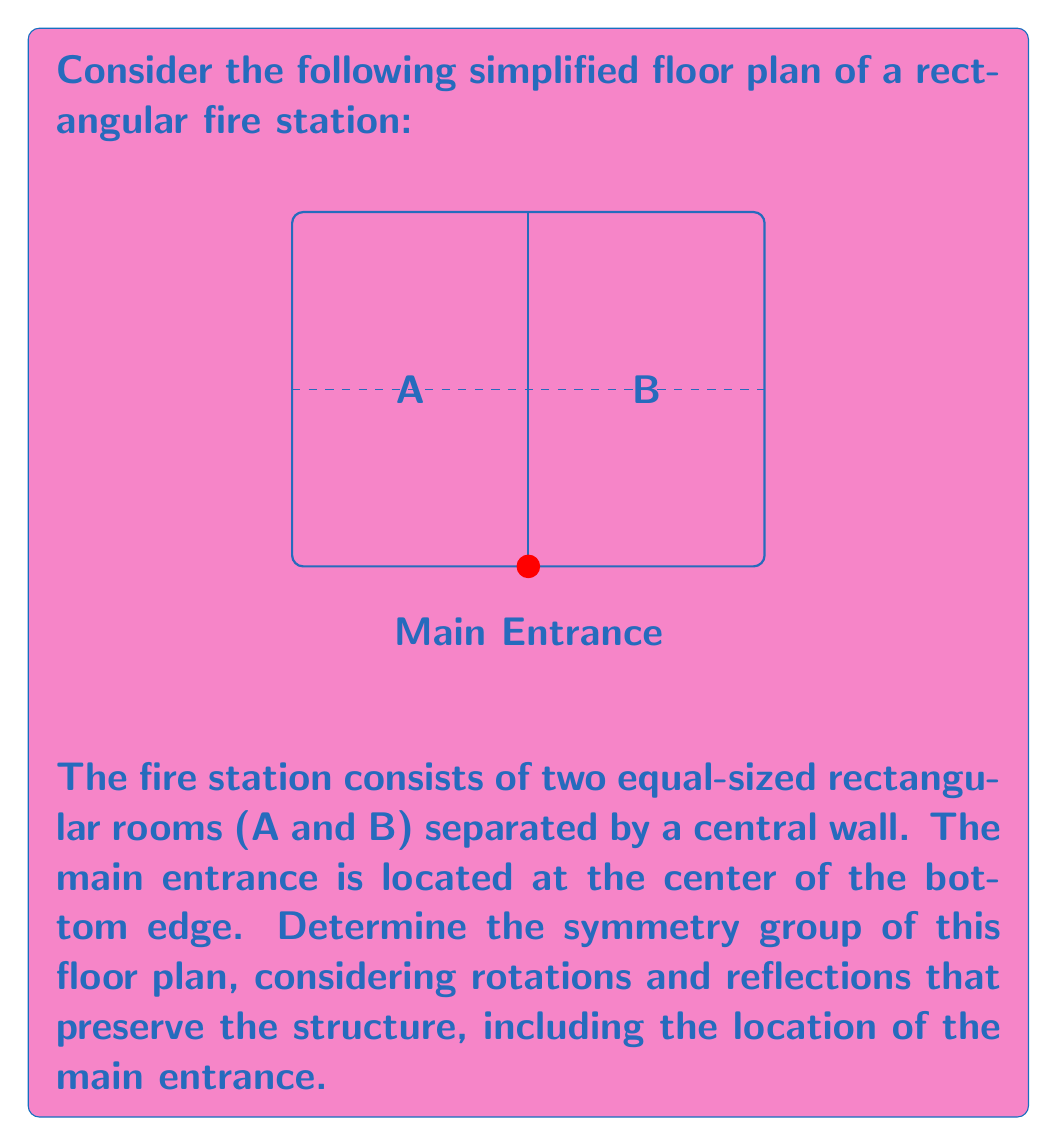Could you help me with this problem? To determine the symmetry group of the fire station floor plan, we need to identify all the symmetries that preserve the structure:

1. Identity (I): The trivial symmetry that leaves the floor plan unchanged.

2. Reflection (R): There is one line of reflection, which is the vertical line passing through the center of the floor plan and the main entrance. This reflection swaps rooms A and B.

3. Rotations: There are no rotations (other than 360°) that preserve the structure, as the main entrance location must remain fixed.

The symmetries we've identified form a group under composition. Let's verify the group properties:

- Closure: I * I = I, I * R = R, R * I = R, R * R = I
- Associativity: This property holds for all symmetry operations
- Identity element: I serves as the identity element
- Inverse element: I is its own inverse, and R is its own inverse

This group has two elements and is isomorphic to the cyclic group of order 2, denoted as $C_2$ or $\mathbb{Z}_2$.

In terms of abstract algebra, this symmetry group is also isomorphic to the dihedral group $D_1$, which is the symmetry group of a line segment.

The group can be represented using the following Cayley table:

$$
\begin{array}{c|cc}
* & I & R \\
\hline
I & I & R \\
R & R & I
\end{array}
$$

This group is abelian (commutative) as R * I = I * R.
Answer: $C_2$ or $\mathbb{Z}_2$ or $D_1$ 